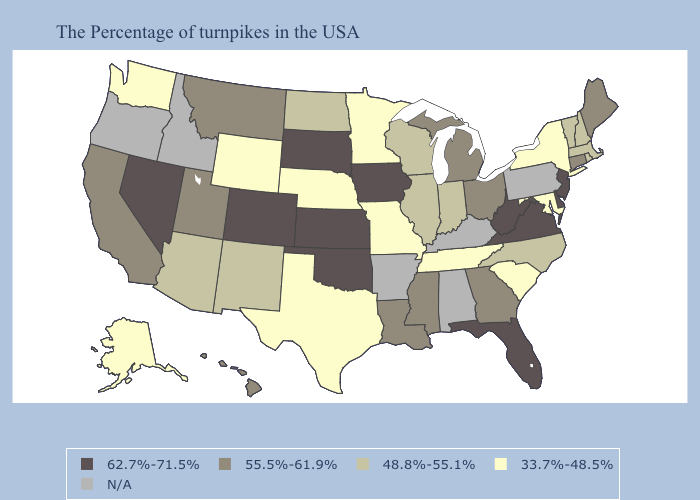Name the states that have a value in the range N/A?
Be succinct. Pennsylvania, Kentucky, Alabama, Arkansas, Idaho, Oregon. Name the states that have a value in the range N/A?
Quick response, please. Pennsylvania, Kentucky, Alabama, Arkansas, Idaho, Oregon. Name the states that have a value in the range N/A?
Answer briefly. Pennsylvania, Kentucky, Alabama, Arkansas, Idaho, Oregon. What is the value of Kansas?
Concise answer only. 62.7%-71.5%. Name the states that have a value in the range 62.7%-71.5%?
Answer briefly. New Jersey, Delaware, Virginia, West Virginia, Florida, Iowa, Kansas, Oklahoma, South Dakota, Colorado, Nevada. Which states have the lowest value in the USA?
Give a very brief answer. New York, Maryland, South Carolina, Tennessee, Missouri, Minnesota, Nebraska, Texas, Wyoming, Washington, Alaska. What is the value of New Hampshire?
Keep it brief. 48.8%-55.1%. What is the value of Georgia?
Short answer required. 55.5%-61.9%. Name the states that have a value in the range N/A?
Concise answer only. Pennsylvania, Kentucky, Alabama, Arkansas, Idaho, Oregon. Name the states that have a value in the range 48.8%-55.1%?
Answer briefly. Massachusetts, Rhode Island, New Hampshire, Vermont, North Carolina, Indiana, Wisconsin, Illinois, North Dakota, New Mexico, Arizona. What is the value of New Hampshire?
Answer briefly. 48.8%-55.1%. Which states have the lowest value in the USA?
Short answer required. New York, Maryland, South Carolina, Tennessee, Missouri, Minnesota, Nebraska, Texas, Wyoming, Washington, Alaska. Name the states that have a value in the range 48.8%-55.1%?
Give a very brief answer. Massachusetts, Rhode Island, New Hampshire, Vermont, North Carolina, Indiana, Wisconsin, Illinois, North Dakota, New Mexico, Arizona. 